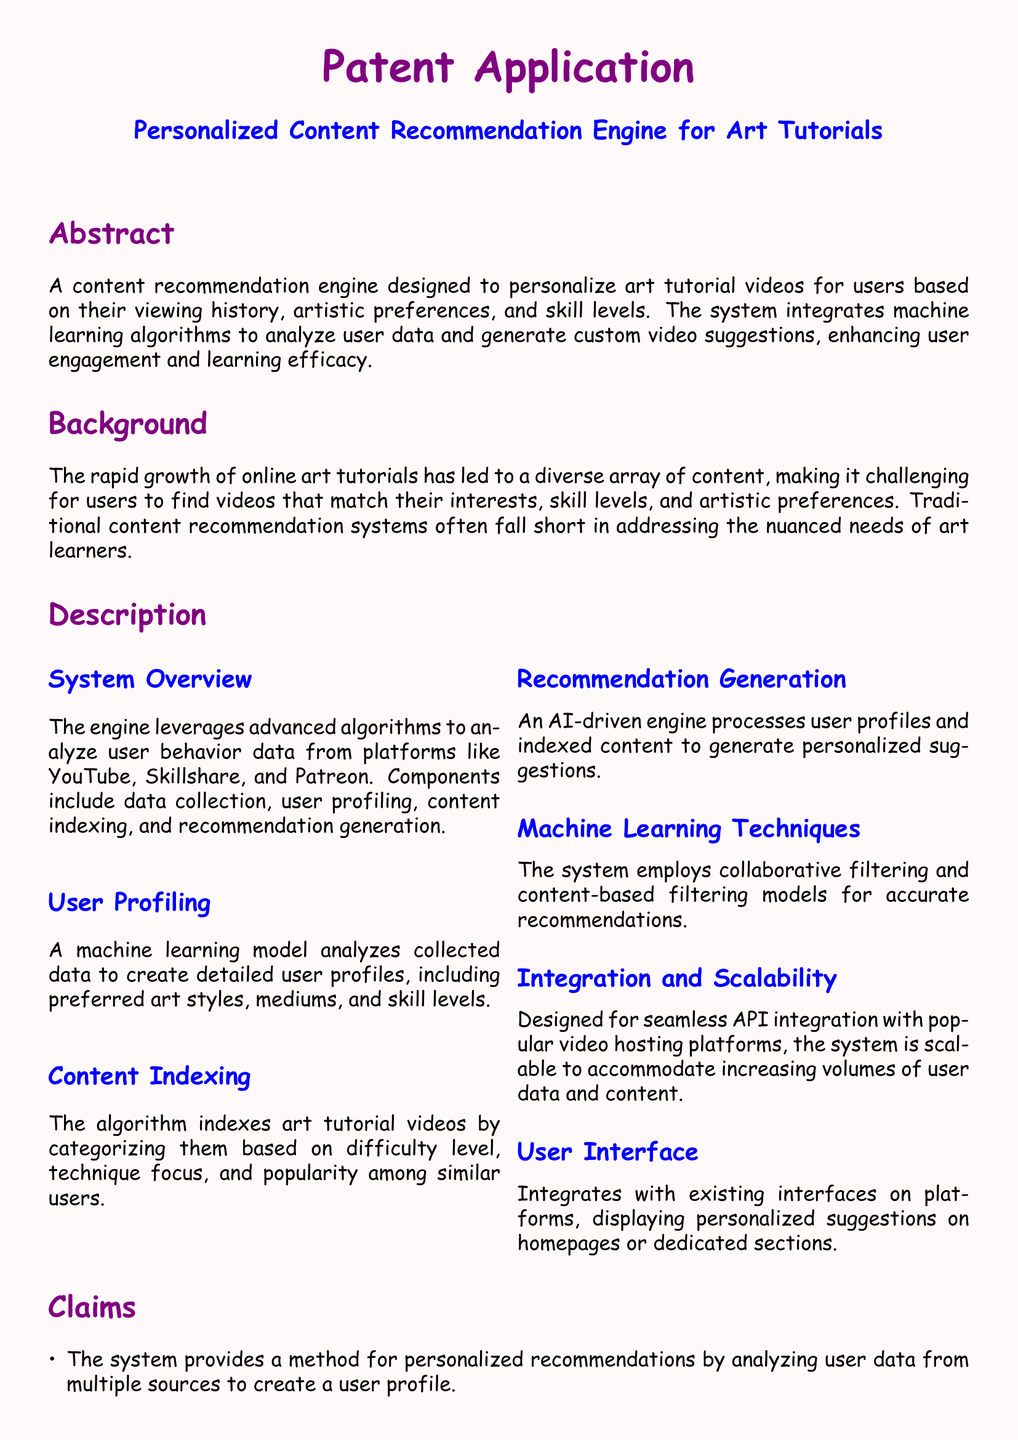What is the title of the patent application? The title is mentioned at the beginning of the document under the header.
Answer: Personalized Content Recommendation Engine for Art Tutorials What is the main purpose of the recommendation engine? The main purpose is described in the abstract section of the document.
Answer: Personalize art tutorial videos How does the system categorize art tutorial videos? The description section lists categories based on certain factors.
Answer: Difficulty level, technique focus, and popularity Which machine learning techniques does the system employ? The techniques are mentioned in the description of the machine learning methods.
Answer: Collaborative filtering and content-based filtering Who can deploy the engine? The applications section outlines who can benefit from this technology.
Answer: Educational platforms, independent artists, and art communities What improves user engagement and learning outcomes according to the claims? The claims highlight how the system achieves better engagement and learning.
Answer: Targeted content delivery tailored to user preferences and skill levels What components are involved in the system overview? The components are introduced in the description of the system overview.
Answer: Data collection, user profiling, content indexing, and recommendation generation How is the user profile created? The method is detailed in the user profiling subsection.
Answer: By analyzing collected data What is the color of the document's background? The background color is specified in the formatting section of the document.
Answer: Light pink 